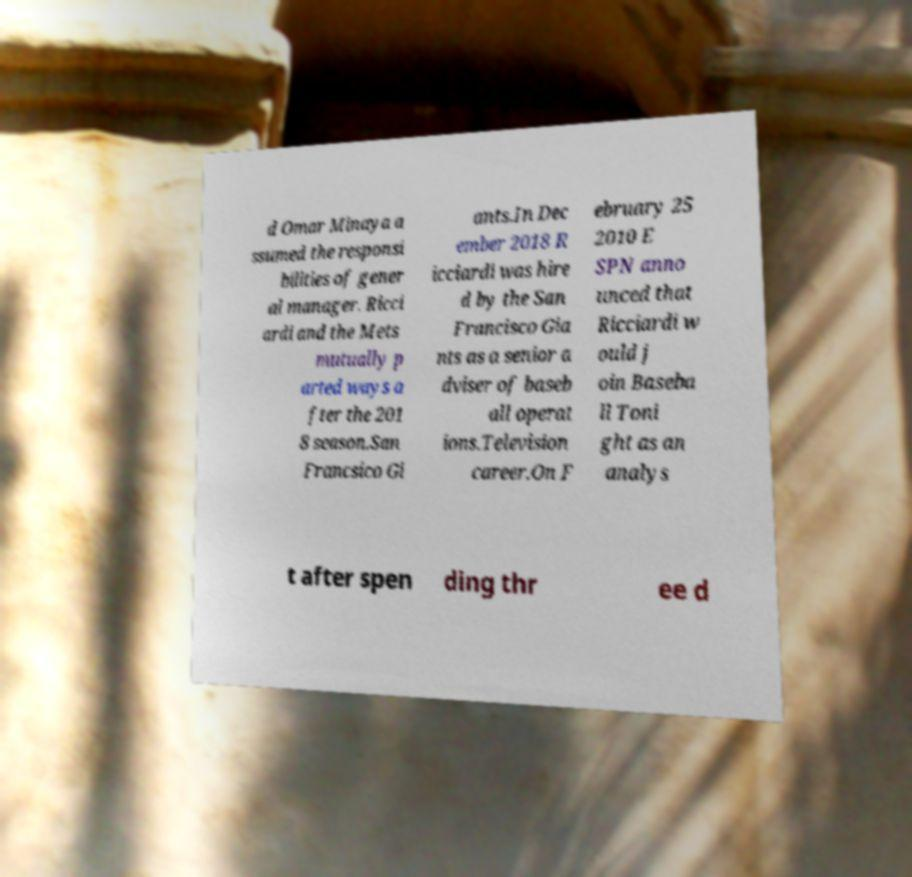Please read and relay the text visible in this image. What does it say? d Omar Minaya a ssumed the responsi bilities of gener al manager. Ricci ardi and the Mets mutually p arted ways a fter the 201 8 season.San Francsico Gi ants.In Dec ember 2018 R icciardi was hire d by the San Francisco Gia nts as a senior a dviser of baseb all operat ions.Television career.On F ebruary 25 2010 E SPN anno unced that Ricciardi w ould j oin Baseba ll Toni ght as an analys t after spen ding thr ee d 